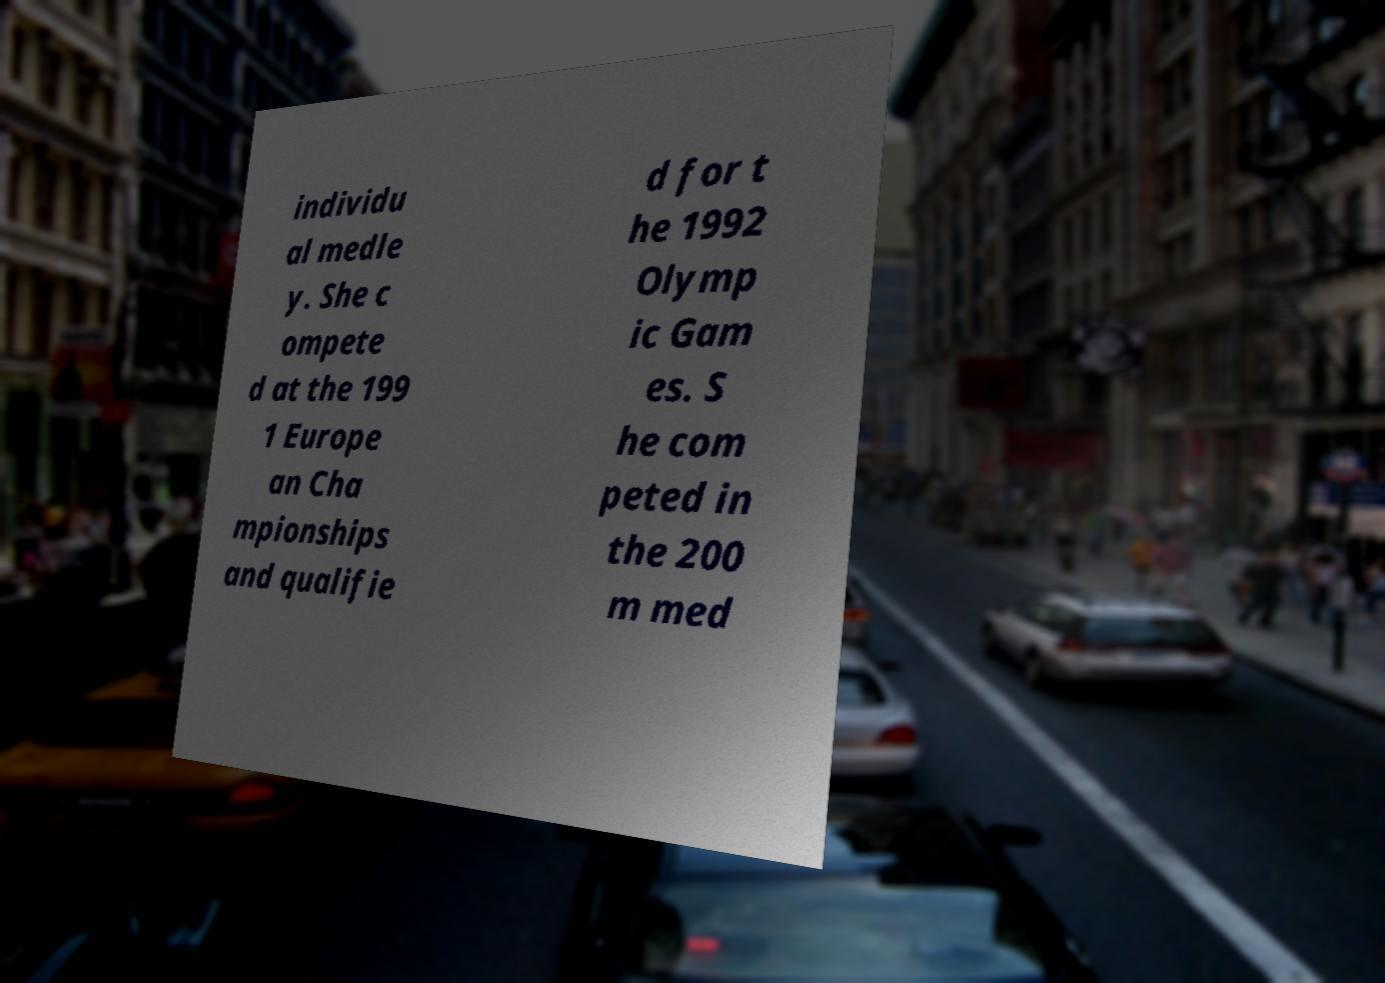Could you assist in decoding the text presented in this image and type it out clearly? individu al medle y. She c ompete d at the 199 1 Europe an Cha mpionships and qualifie d for t he 1992 Olymp ic Gam es. S he com peted in the 200 m med 